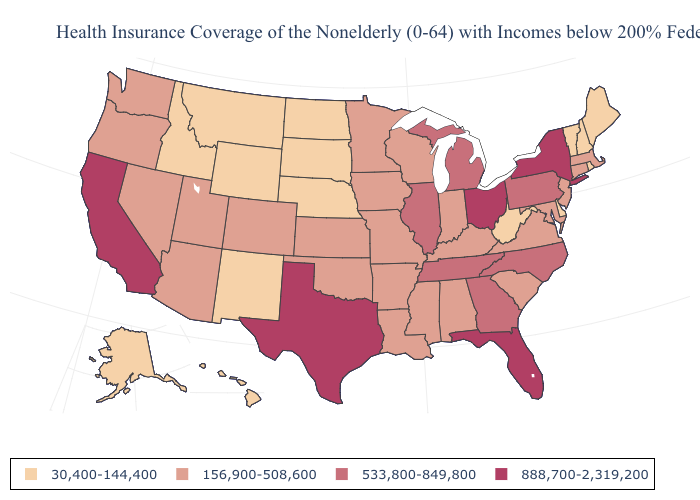Does the first symbol in the legend represent the smallest category?
Give a very brief answer. Yes. Is the legend a continuous bar?
Short answer required. No. Does Washington have the same value as New Hampshire?
Keep it brief. No. What is the value of Louisiana?
Keep it brief. 156,900-508,600. Which states have the lowest value in the USA?
Write a very short answer. Alaska, Delaware, Hawaii, Idaho, Maine, Montana, Nebraska, New Hampshire, New Mexico, North Dakota, Rhode Island, South Dakota, Vermont, West Virginia, Wyoming. What is the lowest value in the USA?
Write a very short answer. 30,400-144,400. Name the states that have a value in the range 30,400-144,400?
Short answer required. Alaska, Delaware, Hawaii, Idaho, Maine, Montana, Nebraska, New Hampshire, New Mexico, North Dakota, Rhode Island, South Dakota, Vermont, West Virginia, Wyoming. Name the states that have a value in the range 533,800-849,800?
Give a very brief answer. Georgia, Illinois, Michigan, North Carolina, Pennsylvania, Tennessee. Name the states that have a value in the range 888,700-2,319,200?
Concise answer only. California, Florida, New York, Ohio, Texas. Name the states that have a value in the range 888,700-2,319,200?
Answer briefly. California, Florida, New York, Ohio, Texas. Name the states that have a value in the range 533,800-849,800?
Answer briefly. Georgia, Illinois, Michigan, North Carolina, Pennsylvania, Tennessee. Does South Dakota have the highest value in the USA?
Keep it brief. No. What is the value of California?
Answer briefly. 888,700-2,319,200. Does the map have missing data?
Keep it brief. No. Name the states that have a value in the range 533,800-849,800?
Short answer required. Georgia, Illinois, Michigan, North Carolina, Pennsylvania, Tennessee. 